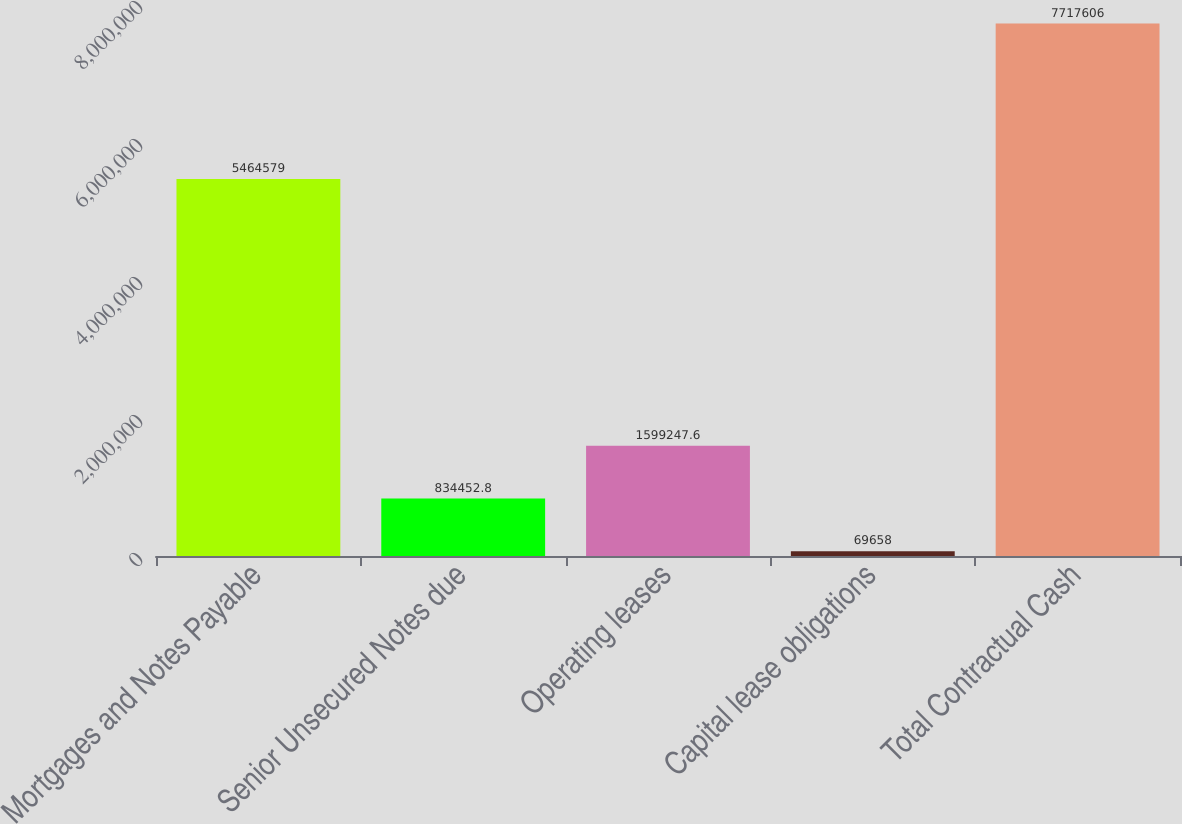Convert chart to OTSL. <chart><loc_0><loc_0><loc_500><loc_500><bar_chart><fcel>Mortgages and Notes Payable<fcel>Senior Unsecured Notes due<fcel>Operating leases<fcel>Capital lease obligations<fcel>Total Contractual Cash<nl><fcel>5.46458e+06<fcel>834453<fcel>1.59925e+06<fcel>69658<fcel>7.71761e+06<nl></chart> 